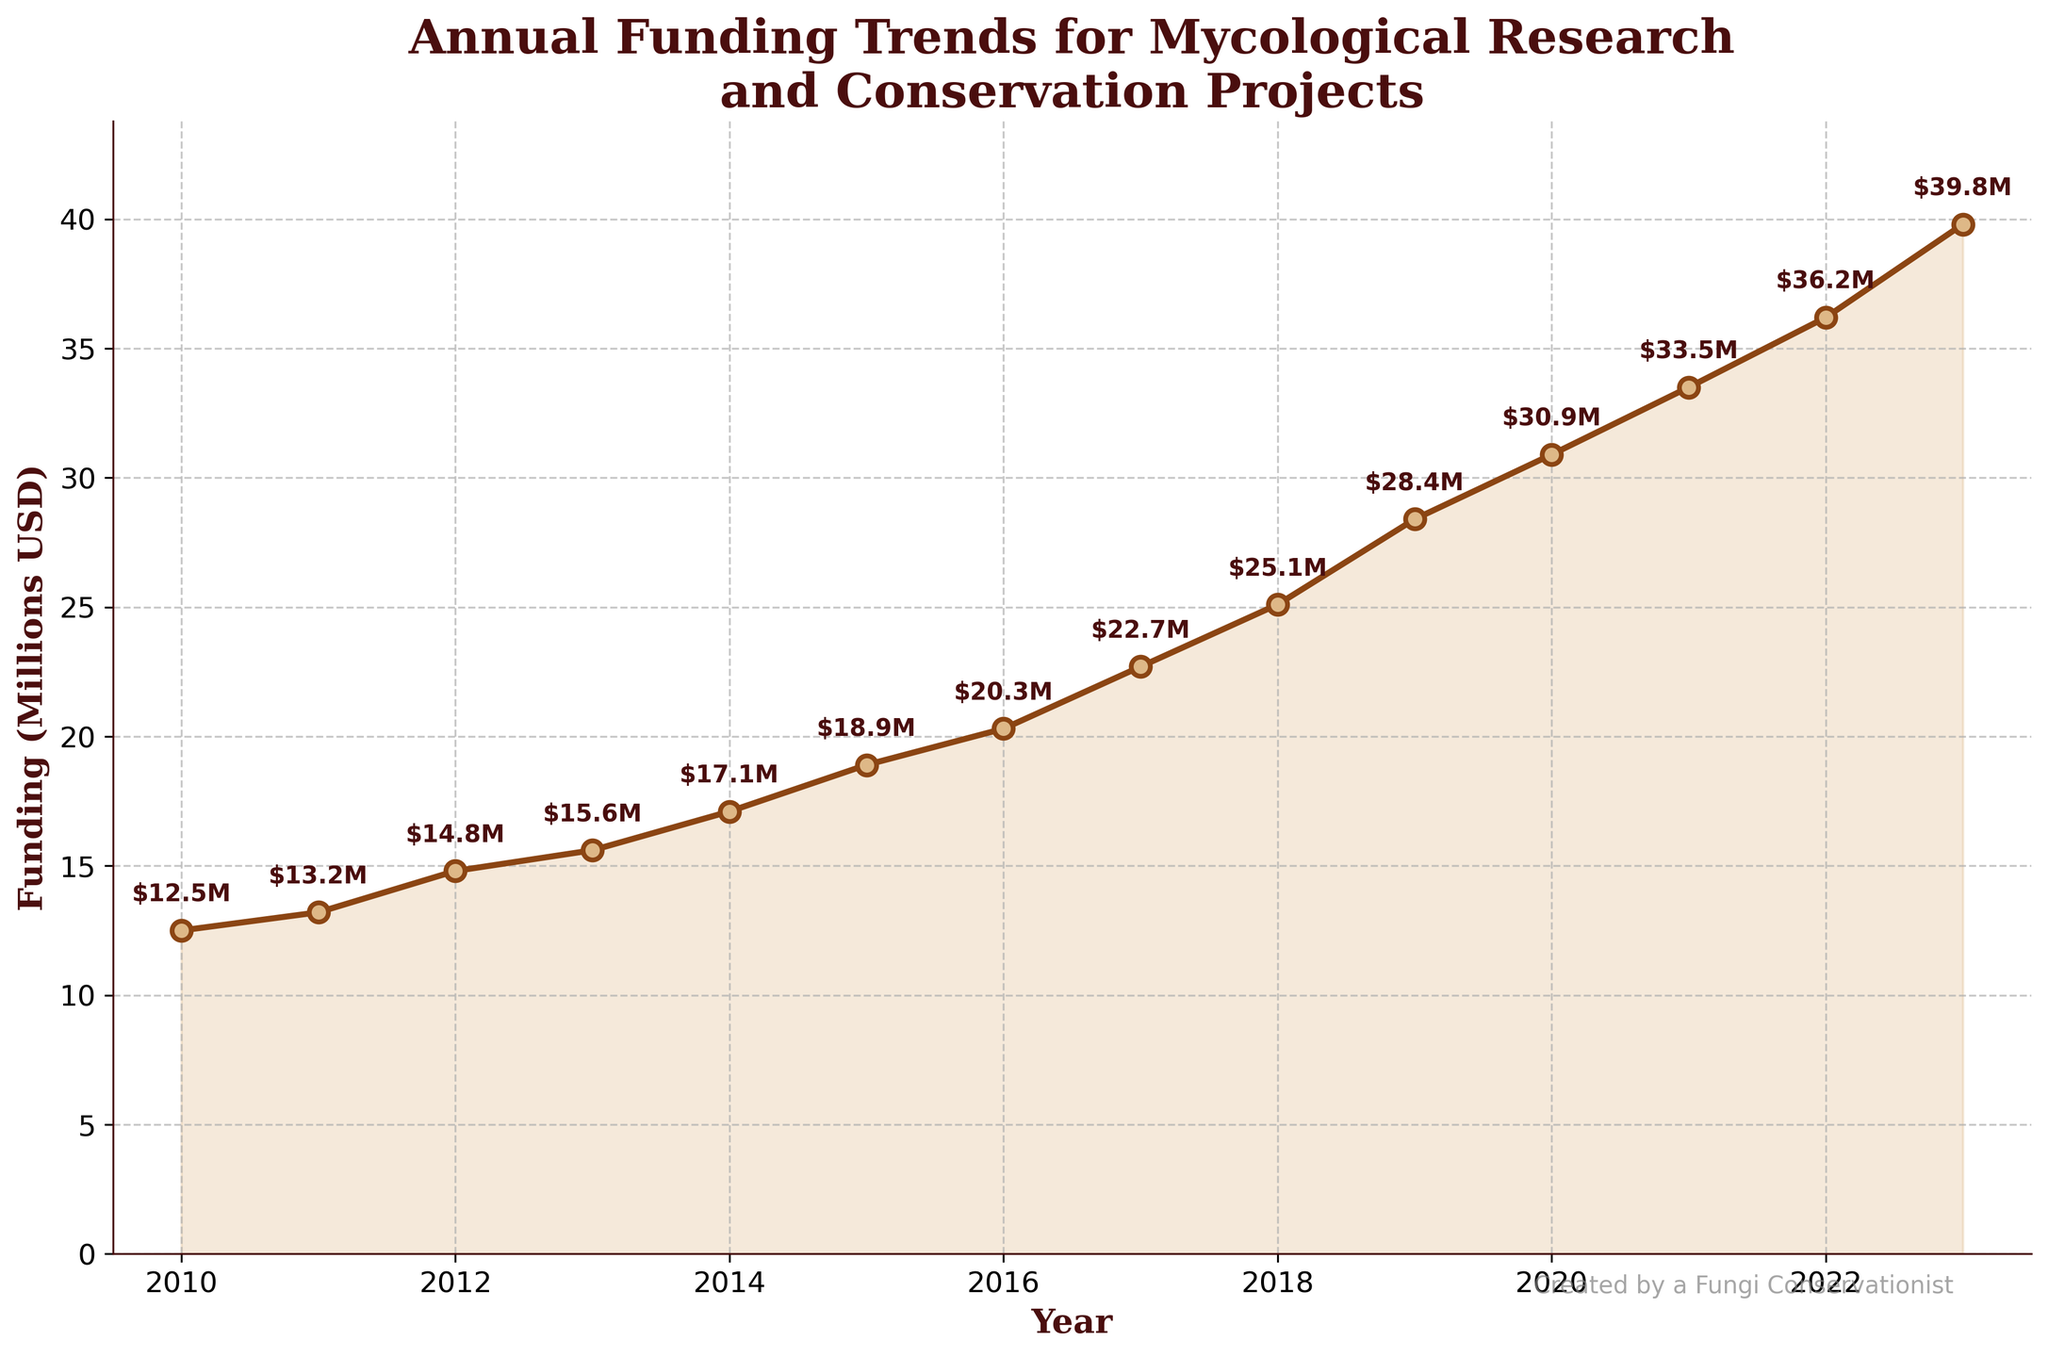What is the overall trend of the annual funding for mycological research and conservation projects from 2010 to 2023? The line chart shows an upward trend from 2010 to 2023, indicating a consistent increase in funding.
Answer: Increasing How much did the funding increase from 2010 to 2023? The funding increased from $12.5 million in 2010 to $39.8 million in 2023, which is an increase of $39.8M - $12.5M = $27.3M.
Answer: $27.3 million Which year saw the largest increase in funding compared to the previous year? To find the year with the largest increase, calculate the differences between consecutive years: the largest difference is between 2019 and 2020, which is $30.9M - $28.4M = $2.5M.
Answer: 2020 What is the average annual funding for mycological research and conservation projects from 2010 to 2023? Sum the funding amounts from 2010 to 2023 and divide by the number of years: ($12.5M + $13.2M + $14.8M + $15.6M + $17.1M + $18.9M + $20.3M + $22.7M + $25.1M + $28.4M + $30.9M + $33.5M + $36.2M + $39.8M) / 14 ≈ $23.98M.
Answer: $24.0 million By how much did the funding increase from 2014 to 2018? The funding increased from $17.1M in 2014 to $25.1M in 2018, which is an increase of $25.1M - $17.1M = $8.0M.
Answer: $8.0 million What is the difference in funding between the year with the highest funding and the year with the lowest funding? The highest funding is in 2023 ($39.8M), and the lowest funding is in 2010 ($12.5M). The difference is $39.8M - $12.5M = $27.3M.
Answer: $27.3 million Which two consecutive years had the smallest increase in funding? Calculate the differences between consecutive years and find the smallest one: the smallest increase is from 2012 to 2013, which is $15.6M - $14.8M = $0.8M.
Answer: 2012-2013 What was the funding in 2016 and how does it compare to the funding in 2012? In 2016, the funding was $20.3M. In 2012, the funding was $14.8M. Comparing the two, $20.3M - $14.8M = $5.5M more in 2016.
Answer: $20.3 million; $5.5 million more 